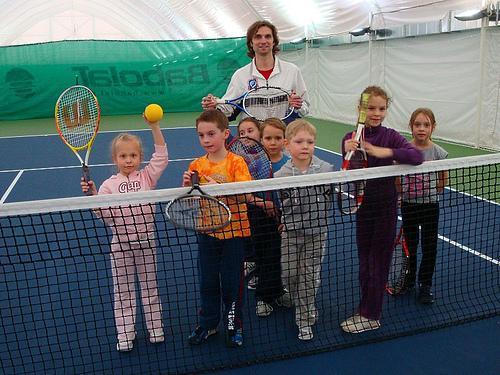How many of the people are kids?
Give a very brief answer. 7. 